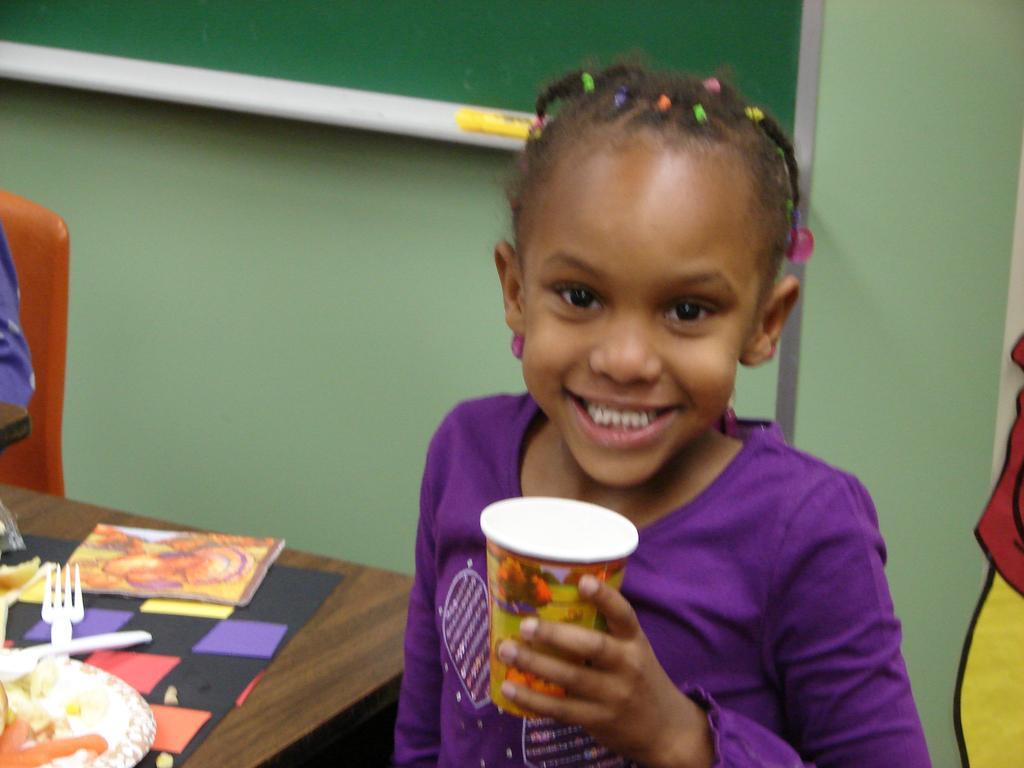Describe this image in one or two sentences. Here I can see a girl wearing a t-shirt, holding a glass in the hand, smiling and giving pose for the picture. On the left side there is a table on which I can see a plate, spoons, a book and some papers. Behind the table there is a person sitting on the chair. In the background there is a wall to which a board is attached. 